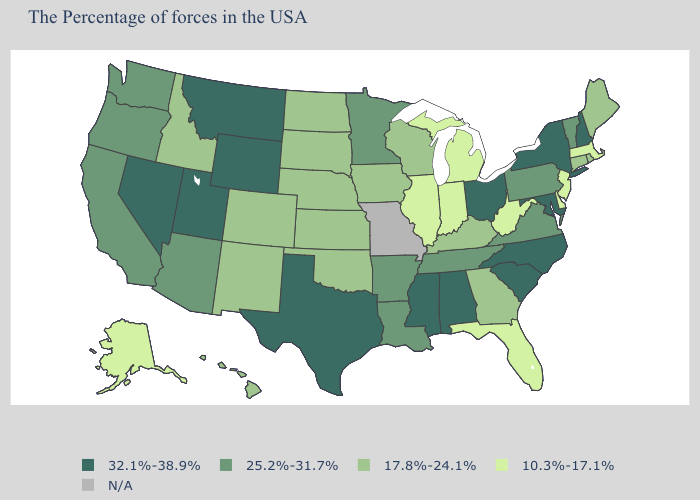Name the states that have a value in the range 17.8%-24.1%?
Short answer required. Maine, Rhode Island, Connecticut, Georgia, Kentucky, Wisconsin, Iowa, Kansas, Nebraska, Oklahoma, South Dakota, North Dakota, Colorado, New Mexico, Idaho, Hawaii. What is the highest value in the South ?
Write a very short answer. 32.1%-38.9%. Among the states that border California , does Nevada have the lowest value?
Keep it brief. No. Which states have the highest value in the USA?
Write a very short answer. New Hampshire, New York, Maryland, North Carolina, South Carolina, Ohio, Alabama, Mississippi, Texas, Wyoming, Utah, Montana, Nevada. Name the states that have a value in the range 10.3%-17.1%?
Keep it brief. Massachusetts, New Jersey, Delaware, West Virginia, Florida, Michigan, Indiana, Illinois, Alaska. What is the value of Oklahoma?
Concise answer only. 17.8%-24.1%. What is the value of Tennessee?
Short answer required. 25.2%-31.7%. Is the legend a continuous bar?
Short answer required. No. What is the value of Vermont?
Answer briefly. 25.2%-31.7%. What is the value of Wyoming?
Be succinct. 32.1%-38.9%. What is the highest value in states that border Montana?
Concise answer only. 32.1%-38.9%. Among the states that border Rhode Island , which have the highest value?
Be succinct. Connecticut. Which states have the lowest value in the South?
Be succinct. Delaware, West Virginia, Florida. 